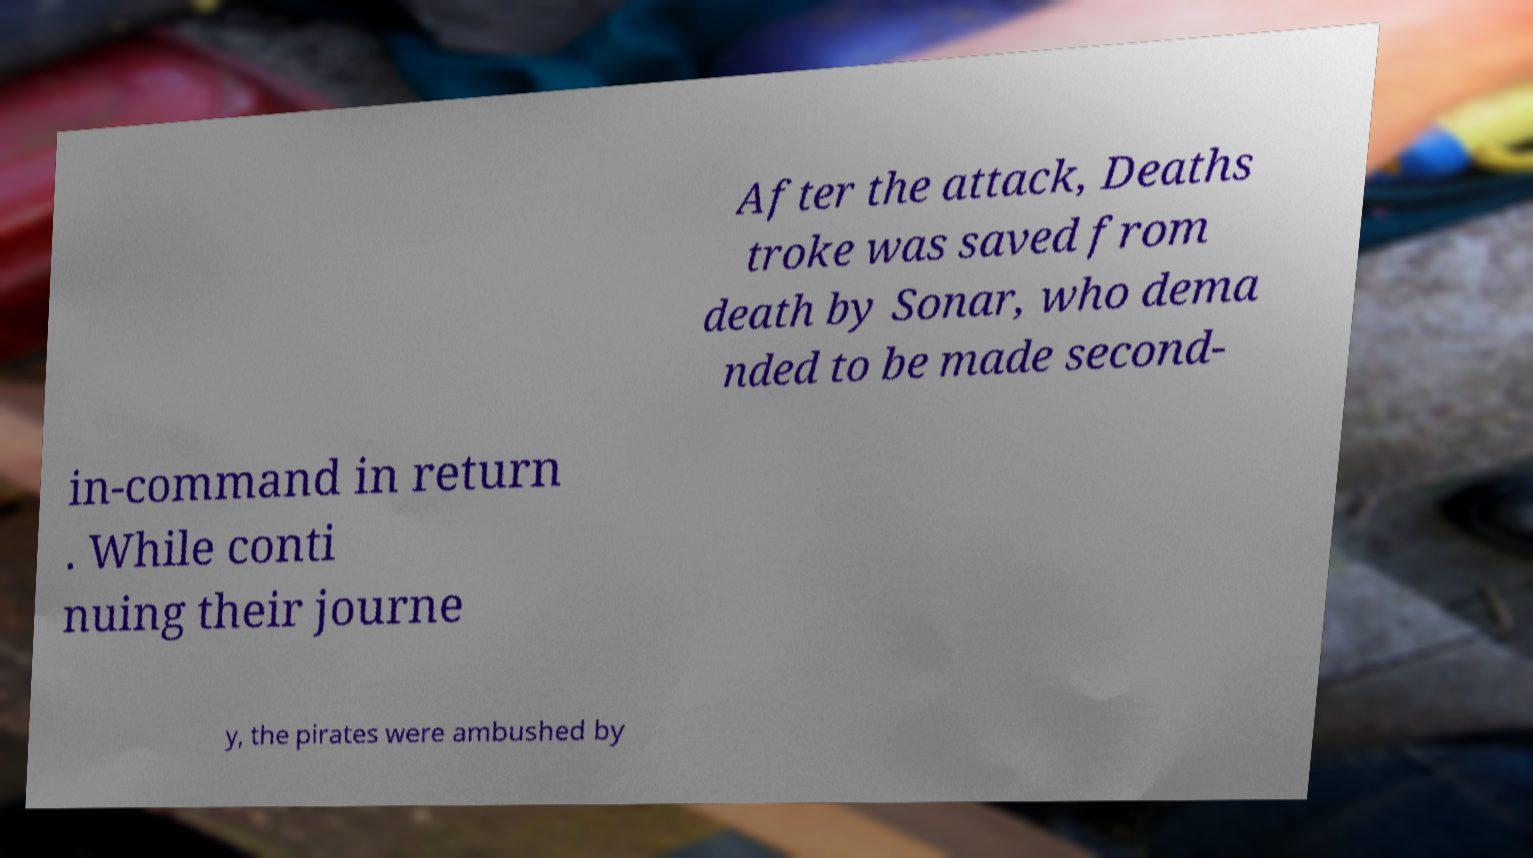Can you accurately transcribe the text from the provided image for me? After the attack, Deaths troke was saved from death by Sonar, who dema nded to be made second- in-command in return . While conti nuing their journe y, the pirates were ambushed by 